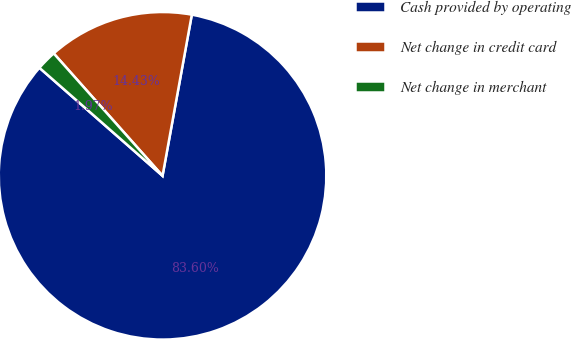<chart> <loc_0><loc_0><loc_500><loc_500><pie_chart><fcel>Cash provided by operating<fcel>Net change in credit card<fcel>Net change in merchant<nl><fcel>83.6%<fcel>14.43%<fcel>1.97%<nl></chart> 